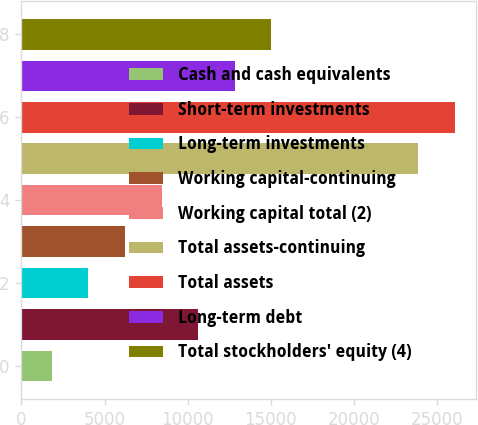Convert chart. <chart><loc_0><loc_0><loc_500><loc_500><bar_chart><fcel>Cash and cash equivalents<fcel>Short-term investments<fcel>Long-term investments<fcel>Working capital-continuing<fcel>Working capital total (2)<fcel>Total assets-continuing<fcel>Total assets<fcel>Long-term debt<fcel>Total stockholders' equity (4)<nl><fcel>1816<fcel>10630<fcel>4019.5<fcel>6223<fcel>8426.5<fcel>23851<fcel>26054.5<fcel>12833.5<fcel>15037<nl></chart> 